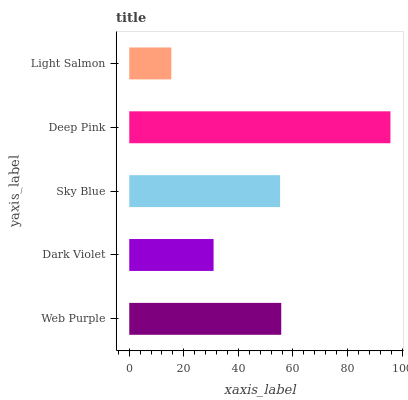Is Light Salmon the minimum?
Answer yes or no. Yes. Is Deep Pink the maximum?
Answer yes or no. Yes. Is Dark Violet the minimum?
Answer yes or no. No. Is Dark Violet the maximum?
Answer yes or no. No. Is Web Purple greater than Dark Violet?
Answer yes or no. Yes. Is Dark Violet less than Web Purple?
Answer yes or no. Yes. Is Dark Violet greater than Web Purple?
Answer yes or no. No. Is Web Purple less than Dark Violet?
Answer yes or no. No. Is Sky Blue the high median?
Answer yes or no. Yes. Is Sky Blue the low median?
Answer yes or no. Yes. Is Web Purple the high median?
Answer yes or no. No. Is Dark Violet the low median?
Answer yes or no. No. 